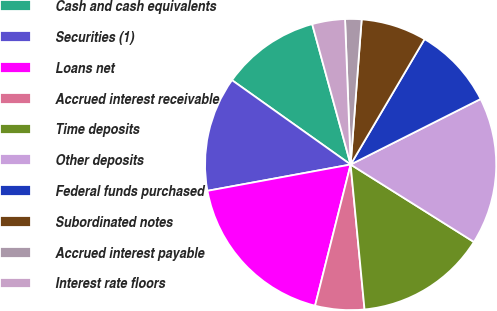<chart> <loc_0><loc_0><loc_500><loc_500><pie_chart><fcel>Cash and cash equivalents<fcel>Securities (1)<fcel>Loans net<fcel>Accrued interest receivable<fcel>Time deposits<fcel>Other deposits<fcel>Federal funds purchased<fcel>Subordinated notes<fcel>Accrued interest payable<fcel>Interest rate floors<nl><fcel>10.91%<fcel>12.73%<fcel>18.18%<fcel>5.45%<fcel>14.55%<fcel>16.36%<fcel>9.09%<fcel>7.27%<fcel>1.82%<fcel>3.64%<nl></chart> 